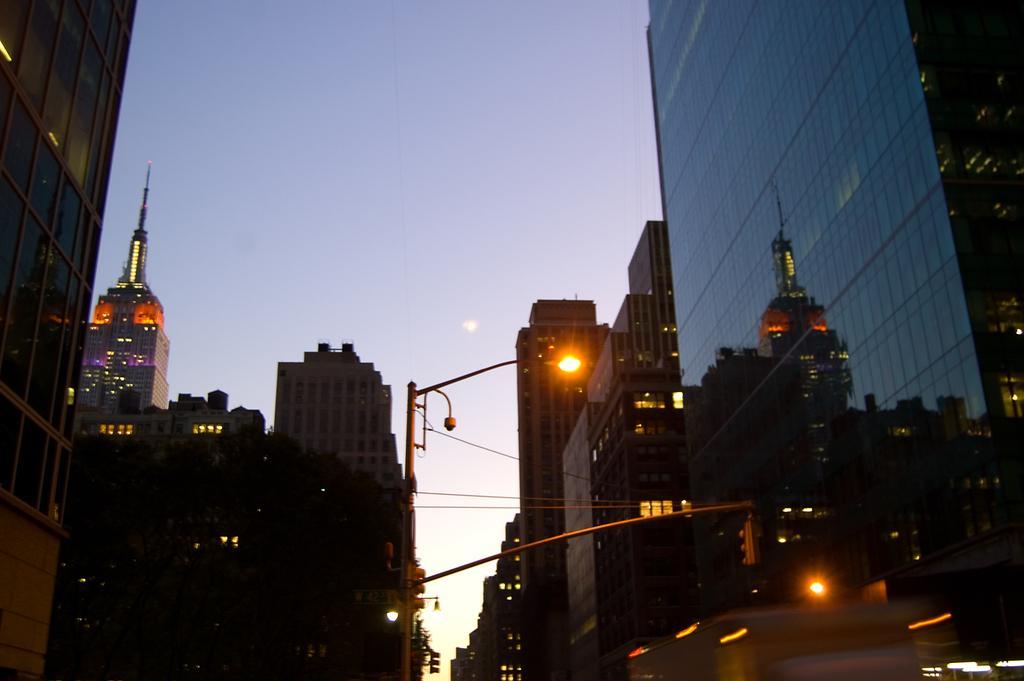Please provide a concise description of this image. In this image there are buildings and light poles, in the background there is the sky. 